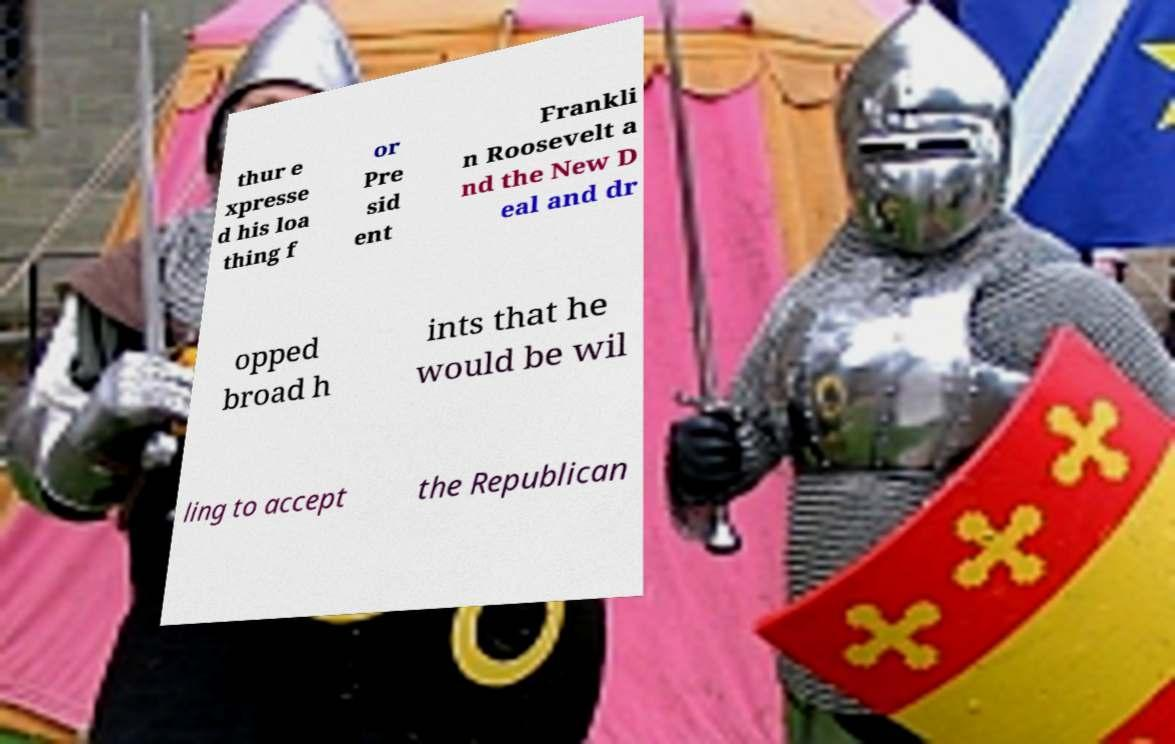There's text embedded in this image that I need extracted. Can you transcribe it verbatim? The image features a piece of paper with text that appears to be about political opinions. The text is cut off and presented in a disorganized way; however, the visible parts seem to express a negative sentiment towards President Franklin Roosevelt and the New Deal. It also suggests the person is open to supporting the Republican party. Due to the fragmented nature of the text, a precise transcription isn't possible from the provided image section, but the gist of the message concerns political preferences. 